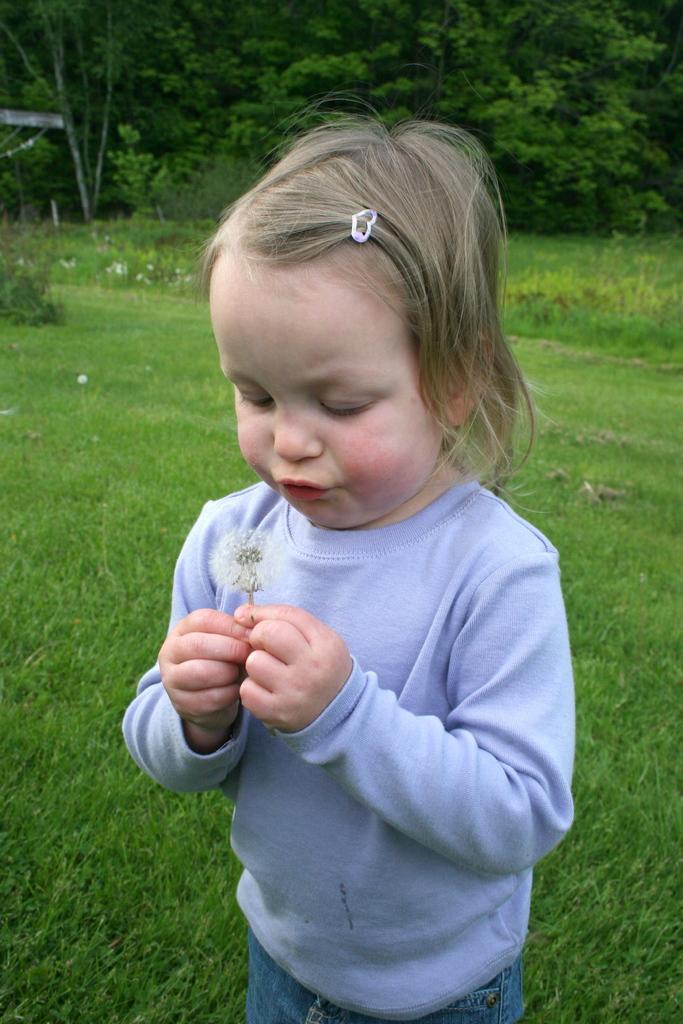Please provide a concise description of this image. In the center of the image there is a girl. In the background of the image there are trees. At the bottom of the image there is grass. 